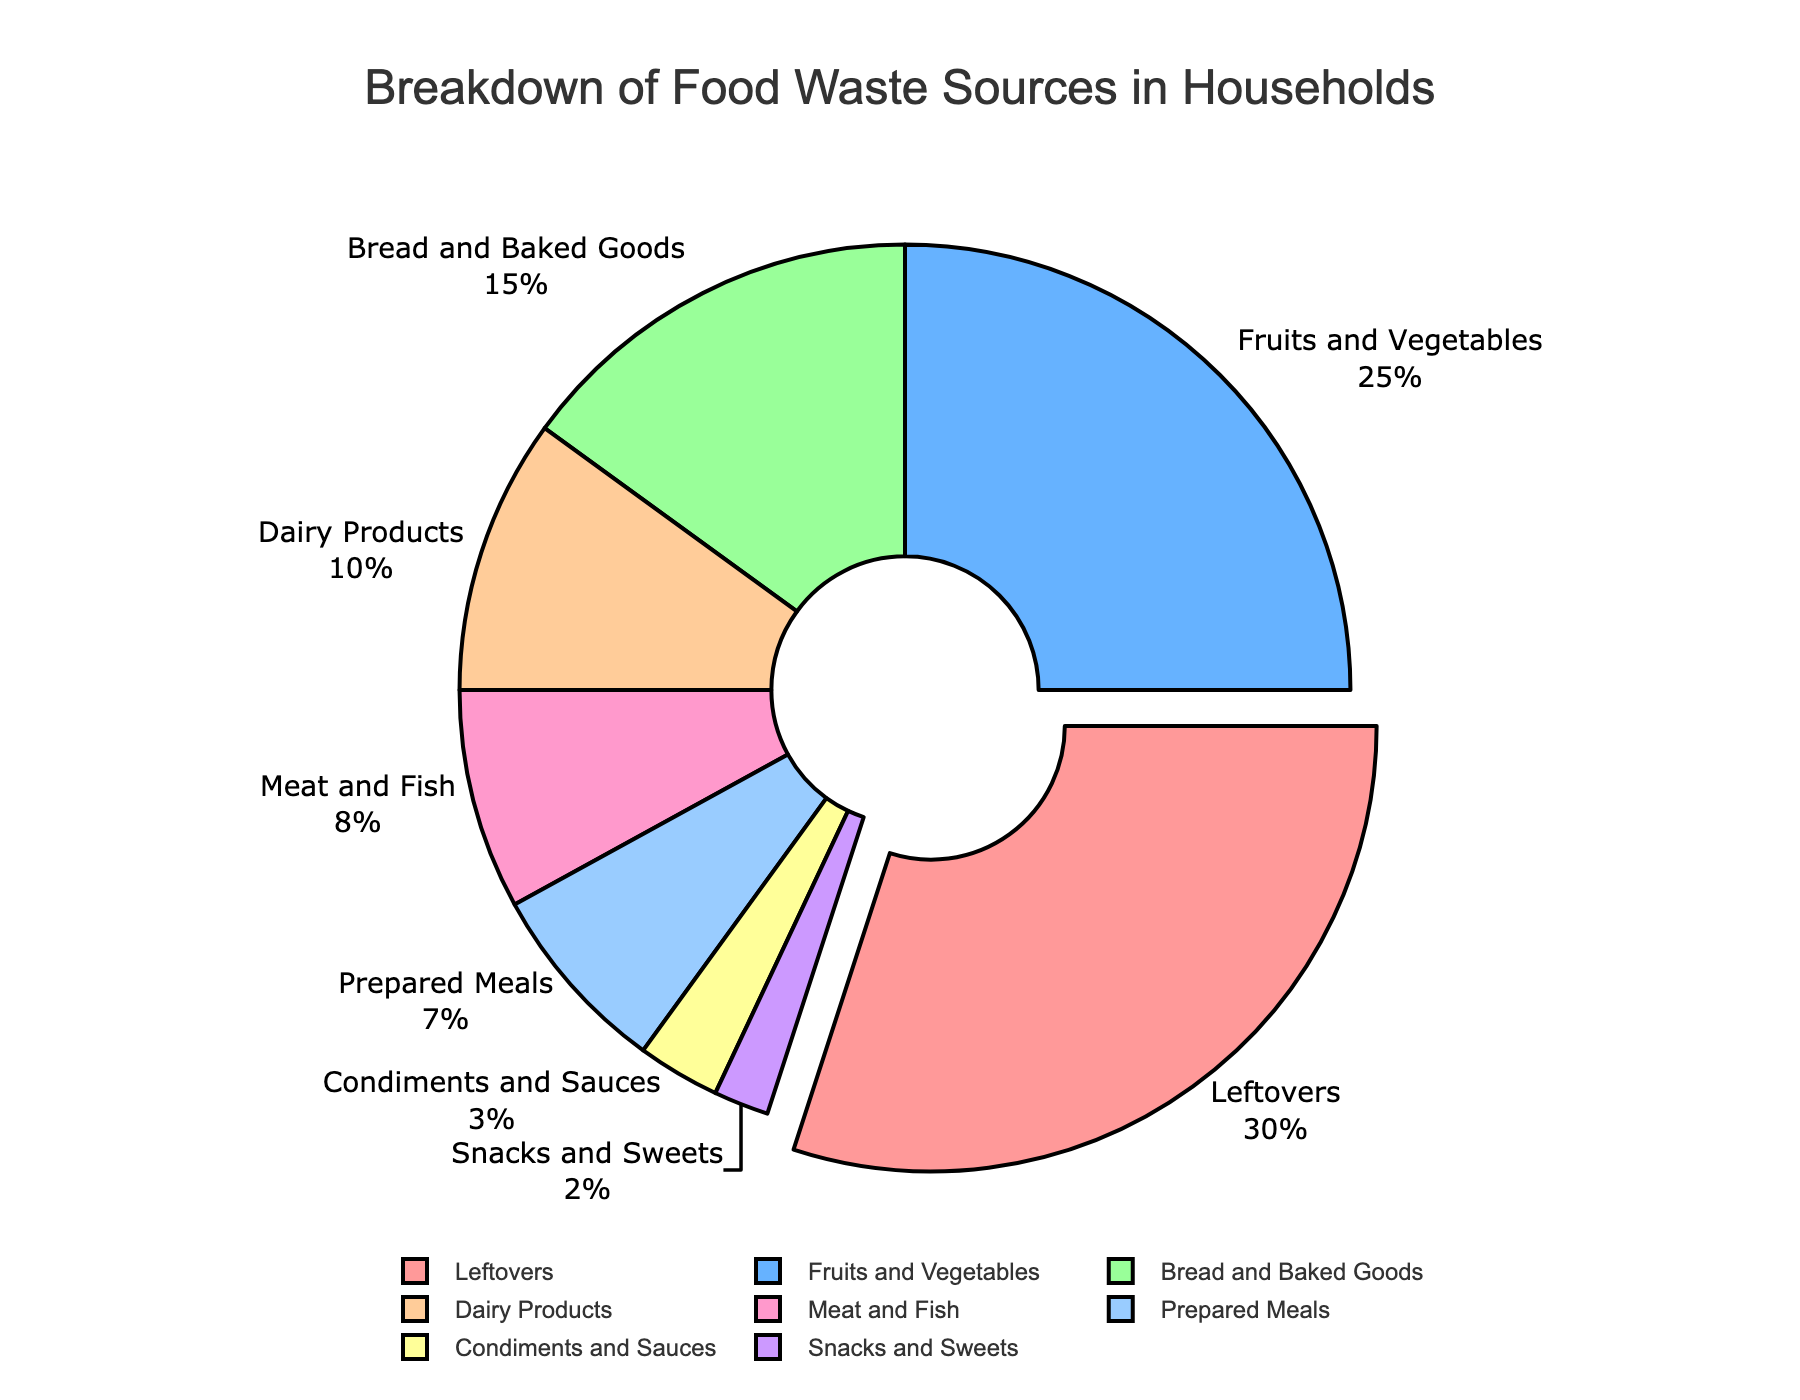Which food type contributes the most to food waste? Leftovers contribute the most. The pie chart shows the largest section labeled "Leftovers" with 30%.
Answer: Leftovers Which two food types contribute equally to food waste? Bread and Baked Goods and Dairy Products contribute equally. By observing the chart, their sections are labeled as 15% and 10% respectively, which are different, so these are incorrect types to compare. The correct types are actually Snacks and Sweets with 2% and Condiments and Sauces with 3%, which the pie chart does not show as equally.
Answer: None What is the sum of the waste percentages for Meat and Fish, and Condiments and Sauces? Add the percentages for Meat and Fish (8%) and Condiments and Sauces (3%): 8% + 3% = 11%.
Answer: 11% How much more percentage does Fruits and Vegetables contribute compared to Meat and Fish? Subtract the percentage of Meat and Fish (8%) from Fruits and Vegetables (25%): 25% - 8% = 17%.
Answer: 17% Which food waste category has a smaller contribution than Bread and Baked Goods but larger than Condiments and Sauces? Bread and Baked Goods is 15%, and Condiments and Sauces is 3%. The category falling between these percentages is Dairy Products at 10%.
Answer: Dairy Products Is the contribution of Snacks and Sweets greater or smaller than that of Prepared Meals? By inspecting the chart, Snacks and Sweets (2%) has a smaller contribution than Prepared Meals (7%).
Answer: Smaller Among all the categories, which has the second smallest waste percentage? By observing the pie chart, the second smallest slice is for Snacks and Sweets at 2%. The smallest is Condiments and Sauces at 3%.
Answer: Snacks and Sweets What percentage of total food waste comes from leftovers and prepared meals together? Add the percentages from Leftovers (30%) and Prepared Meals (7%): 30% + 7% = 37%.
Answer: 37% Which category has half the percentage waste of Fruits and Vegetables? Fruits and Vegetables account for 25%. Half of this value is 12.5%, but by the pie chart, the closest category is Dairy Products at 10%, but this is not an exact half.
Answer: None What aggregate percentage do the top three contributors (Leftovers, Fruits and Vegetables, and Bread and Baked Goods) sum up to? Add their percentages: Leftovers (30%), Fruits and Vegetables (25%), and Bread and Baked Goods (15%): 30% + 25% + 15% = 70%.
Answer: 70% 